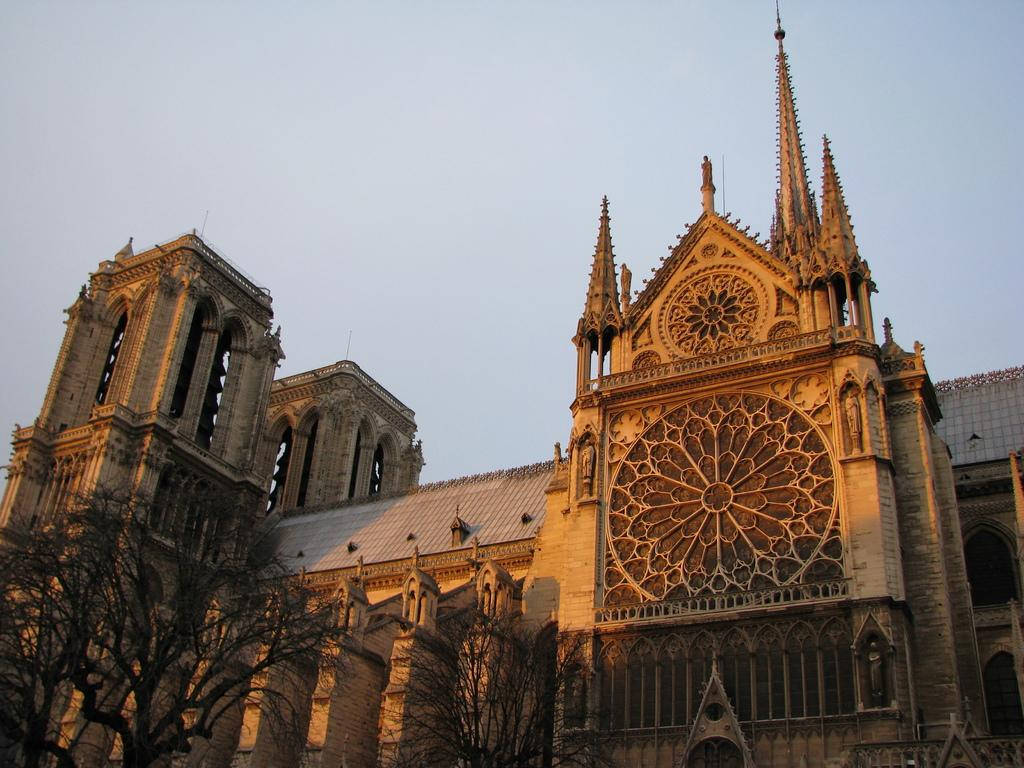What type of vegetation is at the bottom of the image? There are trees at the bottom of the image. What structure is located behind the trees? There is a building behind the trees. What is visible at the top of the image? The sky is visible at the top of the image. What is the profit of the minister in the image? There is no mention of profit or a minister in the image; it features trees, a building, and the sky. How does the rub affect the trees in the image? There is no rub present in the image, so its effect on the trees cannot be determined. 